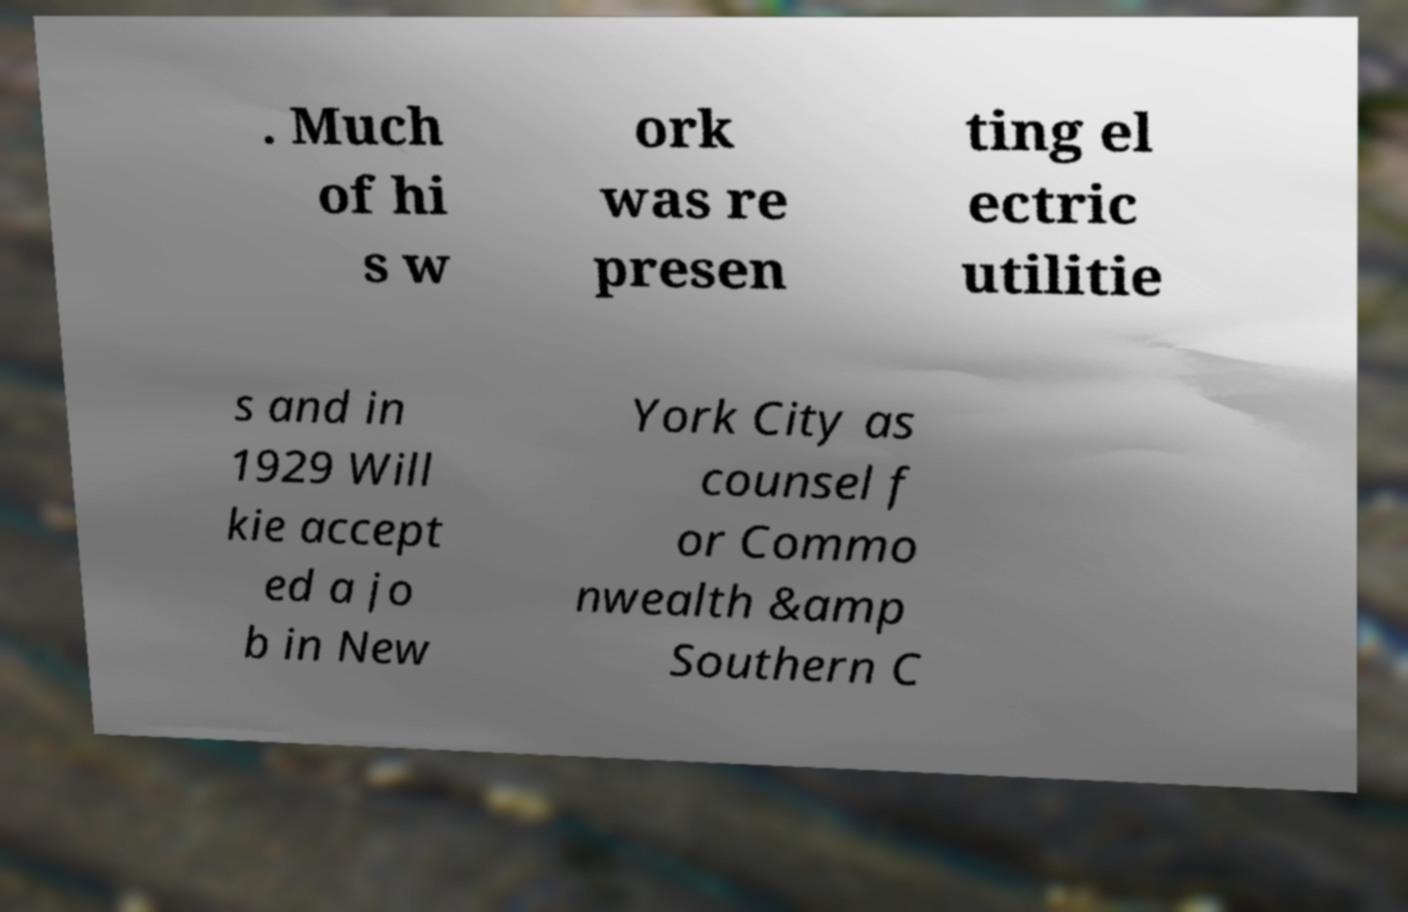Could you assist in decoding the text presented in this image and type it out clearly? . Much of hi s w ork was re presen ting el ectric utilitie s and in 1929 Will kie accept ed a jo b in New York City as counsel f or Commo nwealth &amp Southern C 